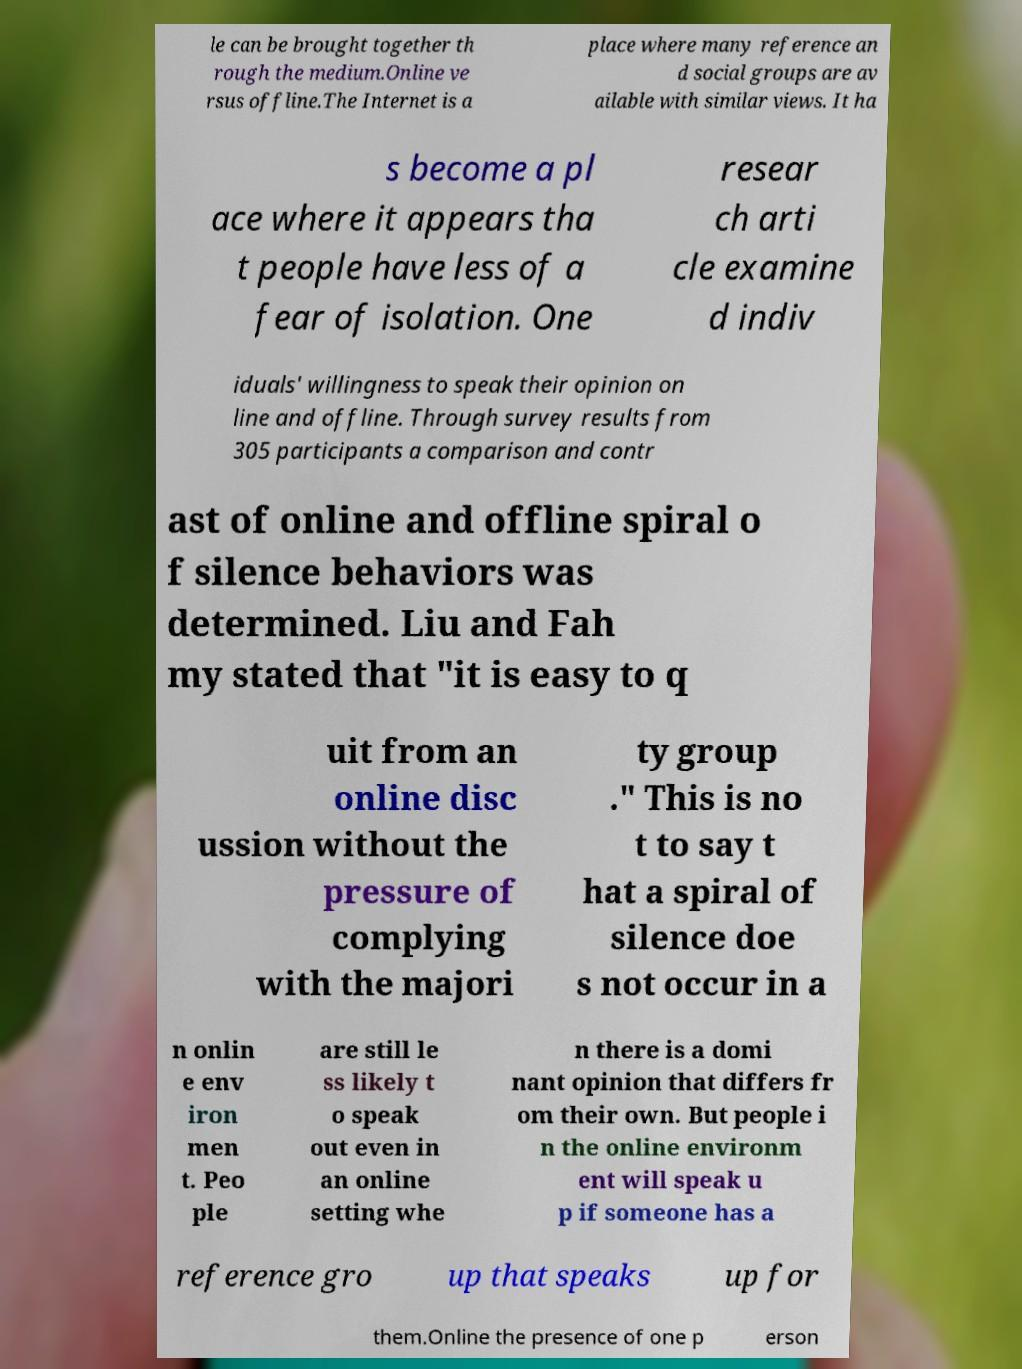There's text embedded in this image that I need extracted. Can you transcribe it verbatim? le can be brought together th rough the medium.Online ve rsus offline.The Internet is a place where many reference an d social groups are av ailable with similar views. It ha s become a pl ace where it appears tha t people have less of a fear of isolation. One resear ch arti cle examine d indiv iduals' willingness to speak their opinion on line and offline. Through survey results from 305 participants a comparison and contr ast of online and offline spiral o f silence behaviors was determined. Liu and Fah my stated that "it is easy to q uit from an online disc ussion without the pressure of complying with the majori ty group ." This is no t to say t hat a spiral of silence doe s not occur in a n onlin e env iron men t. Peo ple are still le ss likely t o speak out even in an online setting whe n there is a domi nant opinion that differs fr om their own. But people i n the online environm ent will speak u p if someone has a reference gro up that speaks up for them.Online the presence of one p erson 